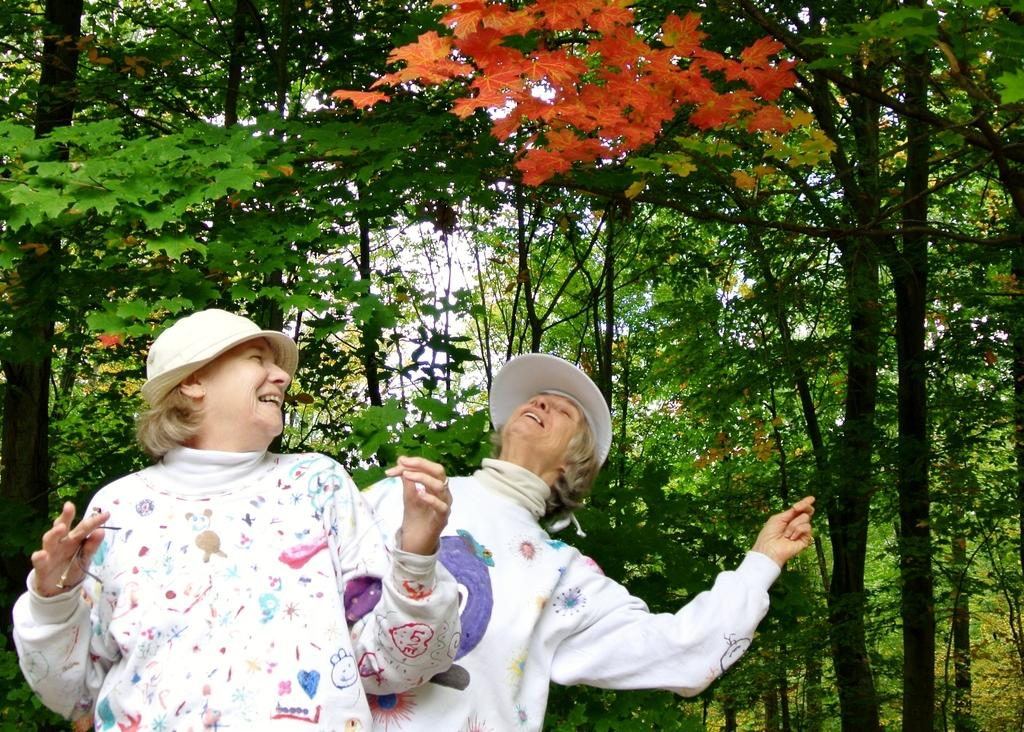How many people are in the image? There are two people in the image. What are the people wearing on their heads? The people are wearing caps. What are the people doing in the image? The people are standing. What can be seen in the background of the image? There is a group of trees and the sky visible in the background of the image. What type of peace symbol can be seen on the stage in the image? There is no peace symbol or stage present in the image. How many hills are visible in the image? There are no hills visible in the image. 